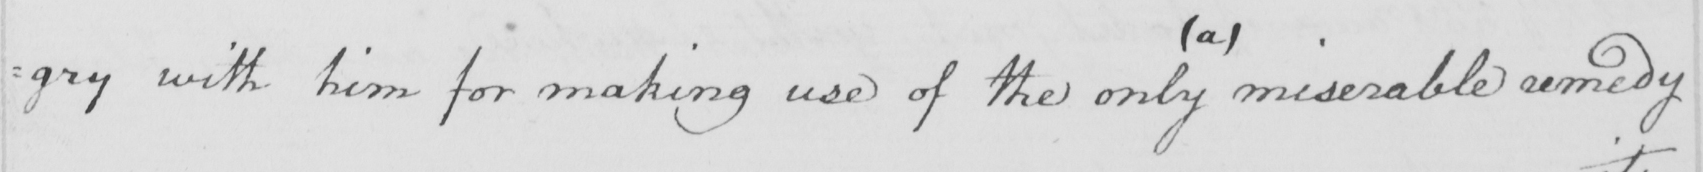What is written in this line of handwriting? : gry with him for making use of the only miserable remedy 